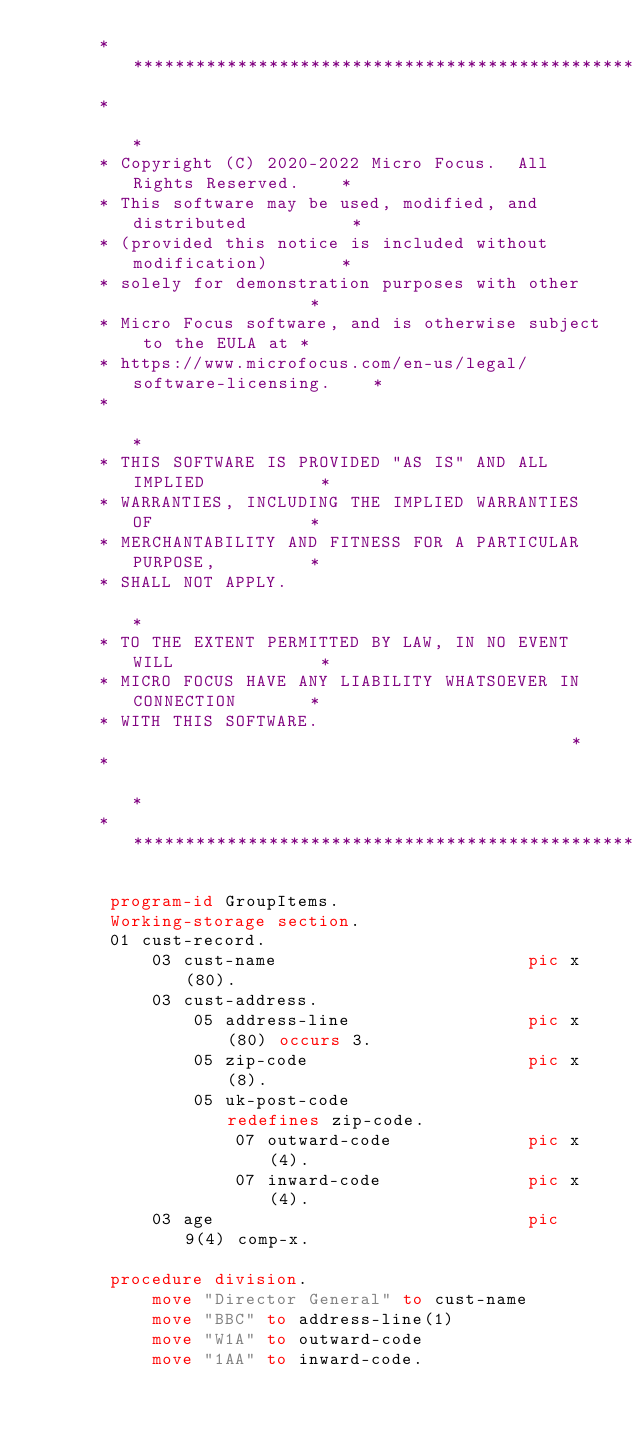<code> <loc_0><loc_0><loc_500><loc_500><_COBOL_>      *****************************************************************
      *                                                               *
      * Copyright (C) 2020-2022 Micro Focus.  All Rights Reserved.    *
      * This software may be used, modified, and distributed          *
      * (provided this notice is included without modification)       *
      * solely for demonstration purposes with other                  *
      * Micro Focus software, and is otherwise subject to the EULA at *
      * https://www.microfocus.com/en-us/legal/software-licensing.    *
      *                                                               *
      * THIS SOFTWARE IS PROVIDED "AS IS" AND ALL IMPLIED           *
      * WARRANTIES, INCLUDING THE IMPLIED WARRANTIES OF               *
      * MERCHANTABILITY AND FITNESS FOR A PARTICULAR PURPOSE,         *
      * SHALL NOT APPLY.                                              *
      * TO THE EXTENT PERMITTED BY LAW, IN NO EVENT WILL              *
      * MICRO FOCUS HAVE ANY LIABILITY WHATSOEVER IN CONNECTION       *
      * WITH THIS SOFTWARE.                                           *
      *                                                               *
      *****************************************************************
      
       program-id GroupItems.
       Working-storage section. 
       01 cust-record. 
           03 cust-name                        pic x(80). 
           03 cust-address.
               05 address-line                 pic x(80) occurs 3.
               05 zip-code                     pic x(8).
               05 uk-post-code                 redefines zip-code.
                   07 outward-code             pic x(4).
                   07 inward-code              pic x(4). 
           03 age                              pic 9(4) comp-x.
         
       procedure division. 
           move "Director General" to cust-name
           move "BBC" to address-line(1) 
           move "W1A" to outward-code
           move "1AA" to inward-code.
</code> 